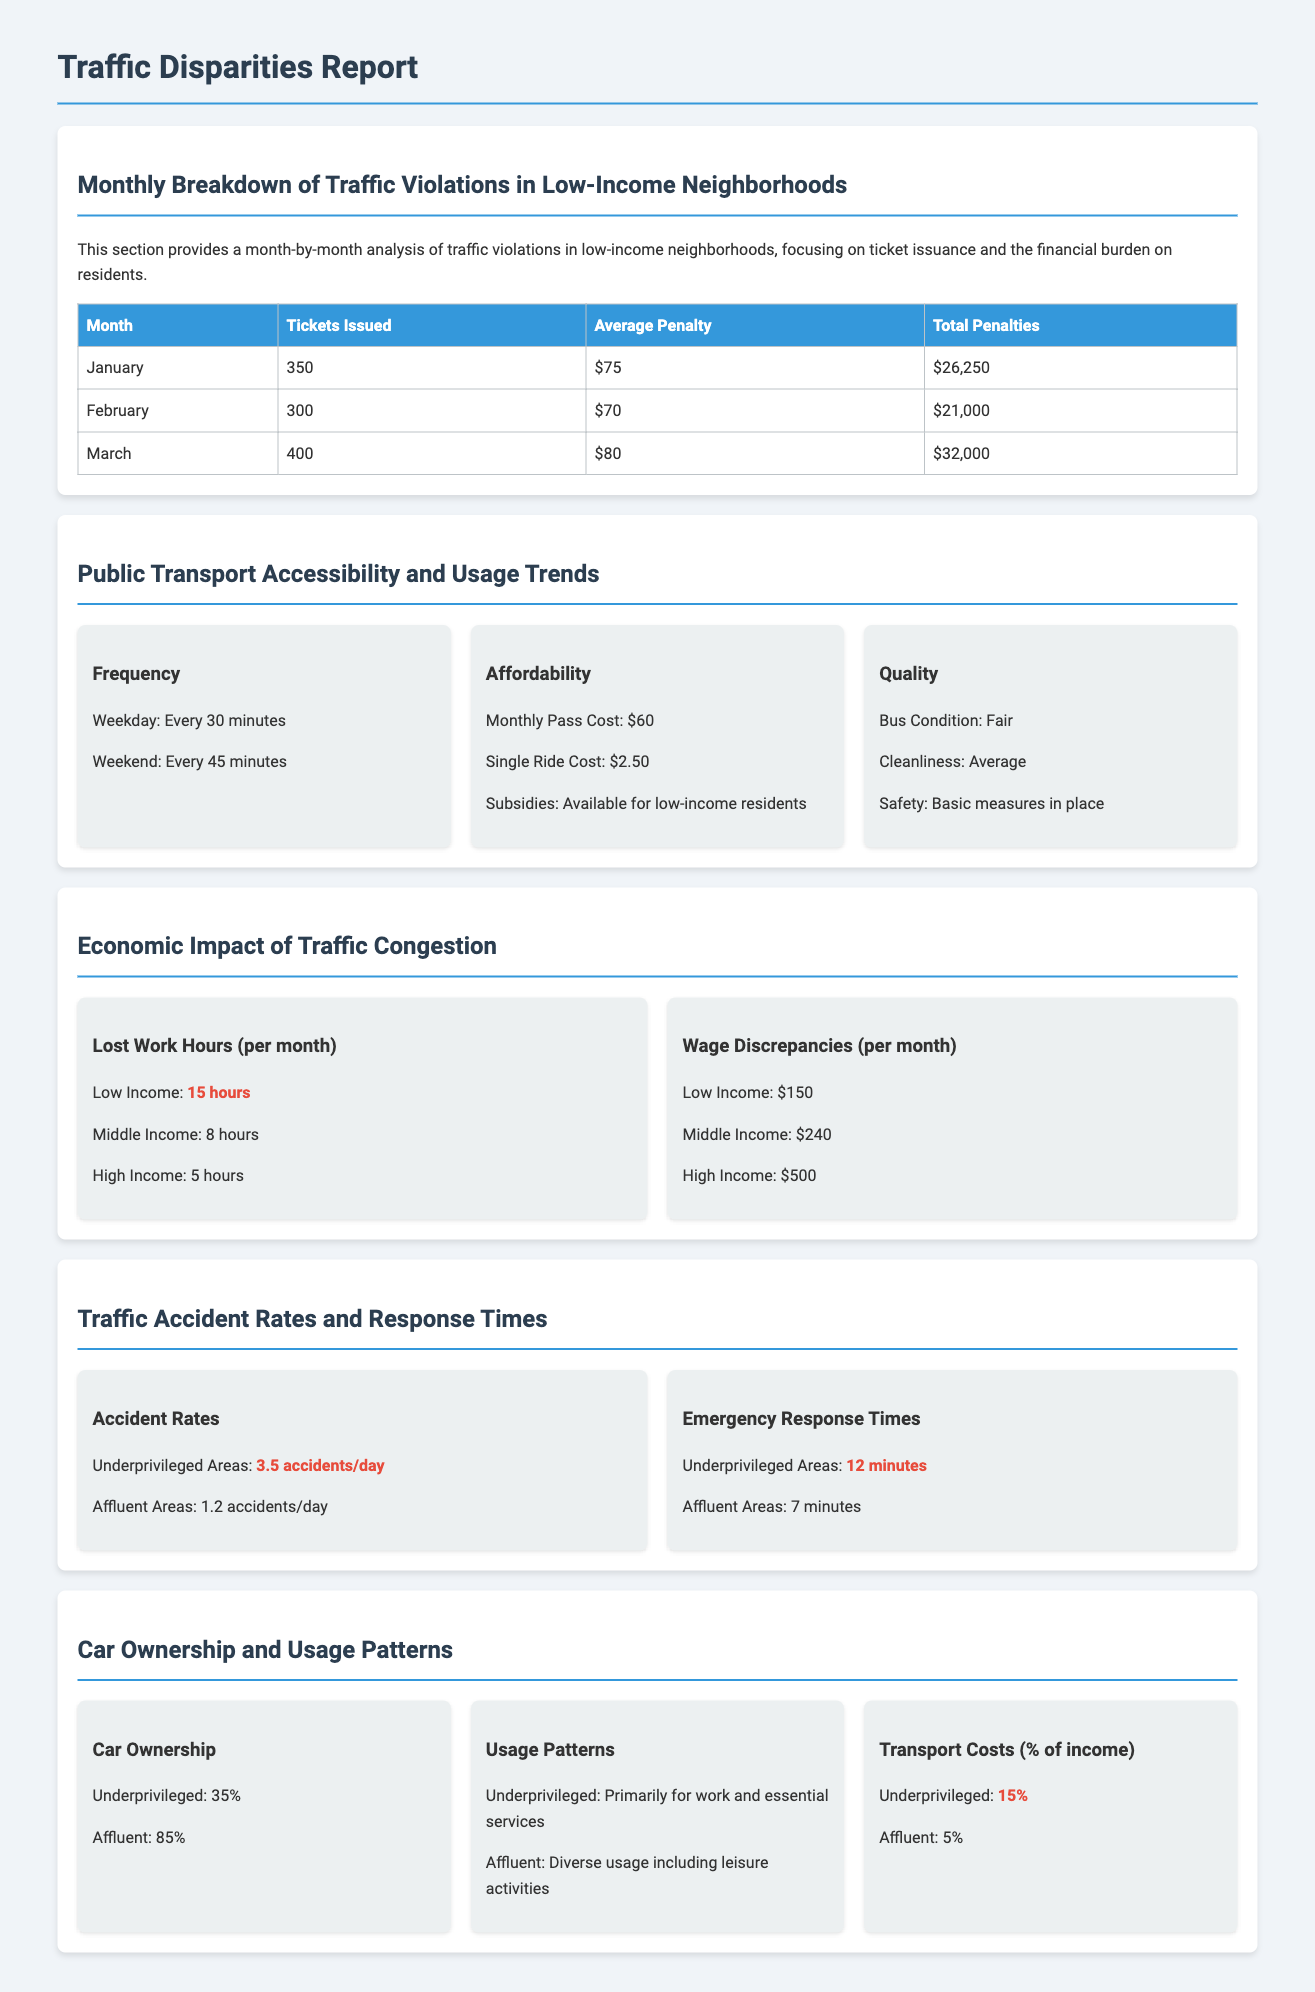What is the average penalty in March? The average penalty issued in March is listed in the Monthly Breakdown of Traffic Violations section as $80.
Answer: $80 How many tickets were issued in January? The document states that 350 tickets were issued in January in the Monthly Breakdown of Traffic Violations section.
Answer: 350 What percentage of underprivileged individuals own cars? In the Car Ownership and Usage Patterns section, it is stated that 35% of underprivileged individuals own cars.
Answer: 35% What is the clean condition of public buses in economically disadvantaged areas? The Quality section notes that the bus condition is described as Fair, which indicates it is not in the best condition.
Answer: Fair What is the difference in lost work hours per month between low-income and high-income individuals? The document mentions that low-income individuals lose 15 hours while high-income individuals lose 5 hours, resulting in a 10-hour difference.
Answer: 10 hours How long does it take for emergency services to respond in underprivileged areas? According to the Traffic Accident Rates and Response Times section, emergency response times in underprivileged areas are stated as 12 minutes.
Answer: 12 minutes What is the single ride cost for public transport? The document indicates that the single ride cost for public transport is $2.50 in the Affordability section.
Answer: $2.50 What is the ratio of accidents in affluent areas compared to underprivileged areas? The document shows that there are 3.5 accidents per day in underprivileged areas and 1.2 in affluent areas, indicating a ratio of approximately 2.92:1.
Answer: 2.92:1 What is the transportation cost as a percentage of income for affluent individuals? The document specifies that transportation costs for affluent individuals account for 5% of their income.
Answer: 5% 